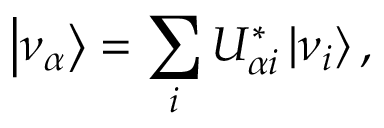<formula> <loc_0><loc_0><loc_500><loc_500>\left | \nu _ { \alpha } \right \rangle = \sum _ { i } U _ { \alpha i } ^ { * } \left | \nu _ { i } \right \rangle ,</formula> 